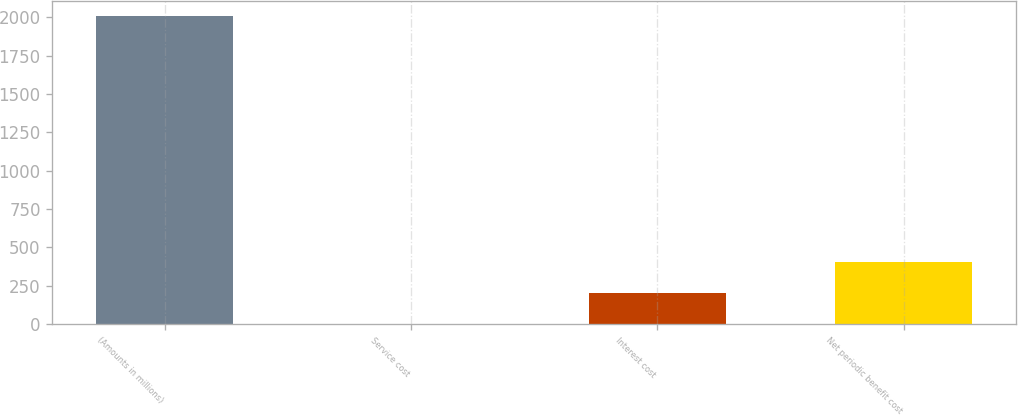Convert chart. <chart><loc_0><loc_0><loc_500><loc_500><bar_chart><fcel>(Amounts in millions)<fcel>Service cost<fcel>Interest cost<fcel>Net periodic benefit cost<nl><fcel>2005<fcel>0.7<fcel>201.13<fcel>401.56<nl></chart> 